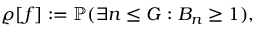Convert formula to latex. <formula><loc_0><loc_0><loc_500><loc_500>\varrho [ f ] \colon = \mathbb { P } ( \exists n \leq G \colon B _ { n } \geq 1 ) ,</formula> 